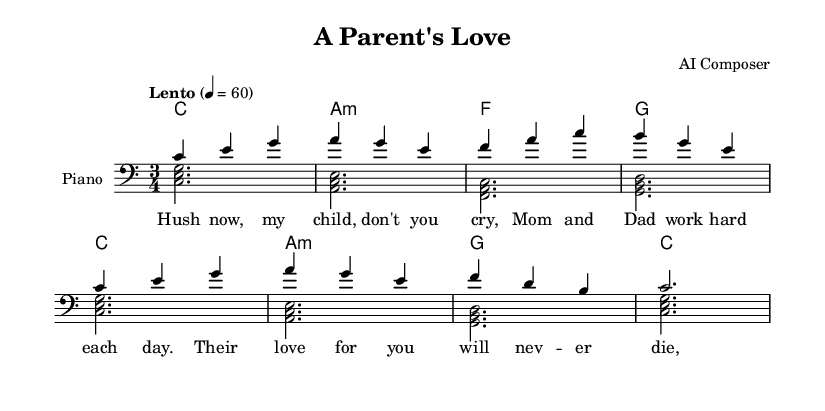What is the key signature of this music? The key signature is C major, which has no sharps or flats.
Answer: C major What is the time signature of this piece? The time signature is indicated in the music notation and shows it's in a 3/4 meter, meaning there are three beats in each measure.
Answer: 3/4 What is the tempo marking for this piece? The tempo marking indicates the speed at which the piece should be played. Here it is marked as "Lento," which means slow, with a metronome marking of 60 beats per minute.
Answer: Lento How many measures are in the melody? Counting the measures in the melody, we see there are a total of eight measures present in this segment.
Answer: 8 What chord is played in measure four? Analyzing the harmonies, we see that the chord played in measure four is G major, which is indicated in the chord symbols.
Answer: G What does the lyric "Their love for you will nev -- er die" express in the context of the lullaby? This lyric expresses the deep and everlasting love that parents have for their child, reflecting a theme of sacrifice and devotion typical in lullabies.
Answer: Everlasting love Which instrument is indicated for the performance of this piece? The score specifies the instrument as "Piano," which is used to accompany the voice and provide harmony.
Answer: Piano 